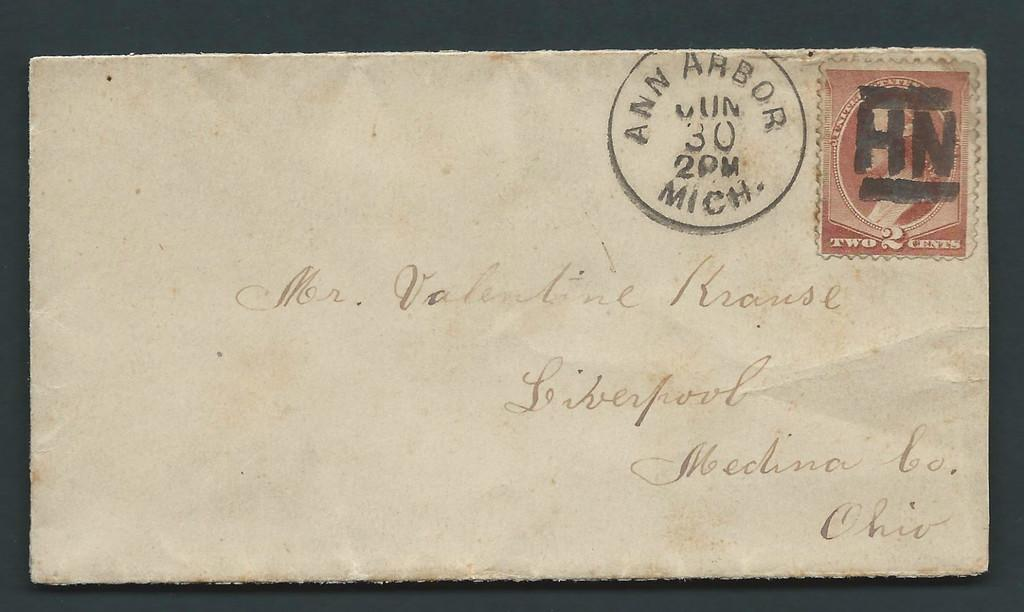<image>
Give a short and clear explanation of the subsequent image. An envelope with a red stamp and a post mark from Ann Arbor, Michigan. 